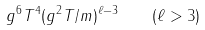Convert formula to latex. <formula><loc_0><loc_0><loc_500><loc_500>g ^ { 6 } T ^ { 4 } ( g ^ { 2 } T / m ) ^ { \ell - 3 } \quad ( \ell > 3 )</formula> 